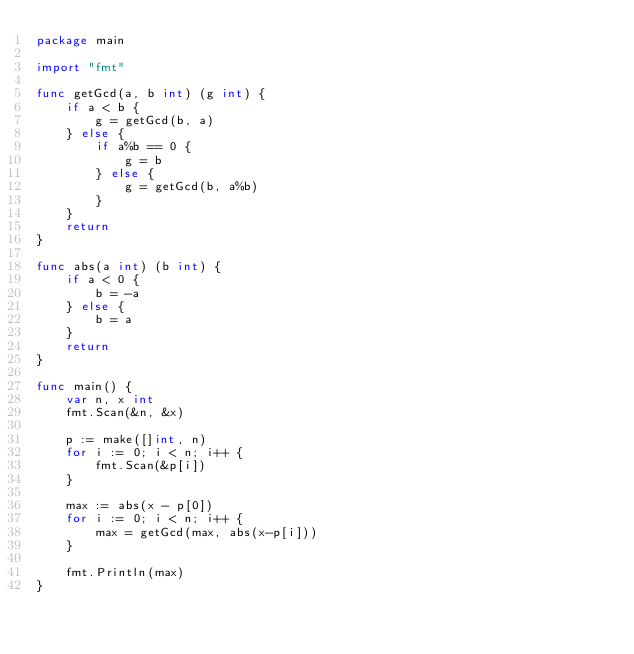<code> <loc_0><loc_0><loc_500><loc_500><_Go_>package main

import "fmt"

func getGcd(a, b int) (g int) {
	if a < b {
		g = getGcd(b, a)
	} else {
		if a%b == 0 {
			g = b
		} else {
			g = getGcd(b, a%b)
		}
	}
	return
}

func abs(a int) (b int) {
	if a < 0 {
		b = -a
	} else {
		b = a
	}
	return
}

func main() {
	var n, x int
	fmt.Scan(&n, &x)

	p := make([]int, n)
	for i := 0; i < n; i++ {
		fmt.Scan(&p[i])
	}

	max := abs(x - p[0])
	for i := 0; i < n; i++ {
		max = getGcd(max, abs(x-p[i]))
	}

	fmt.Println(max)
}
</code> 